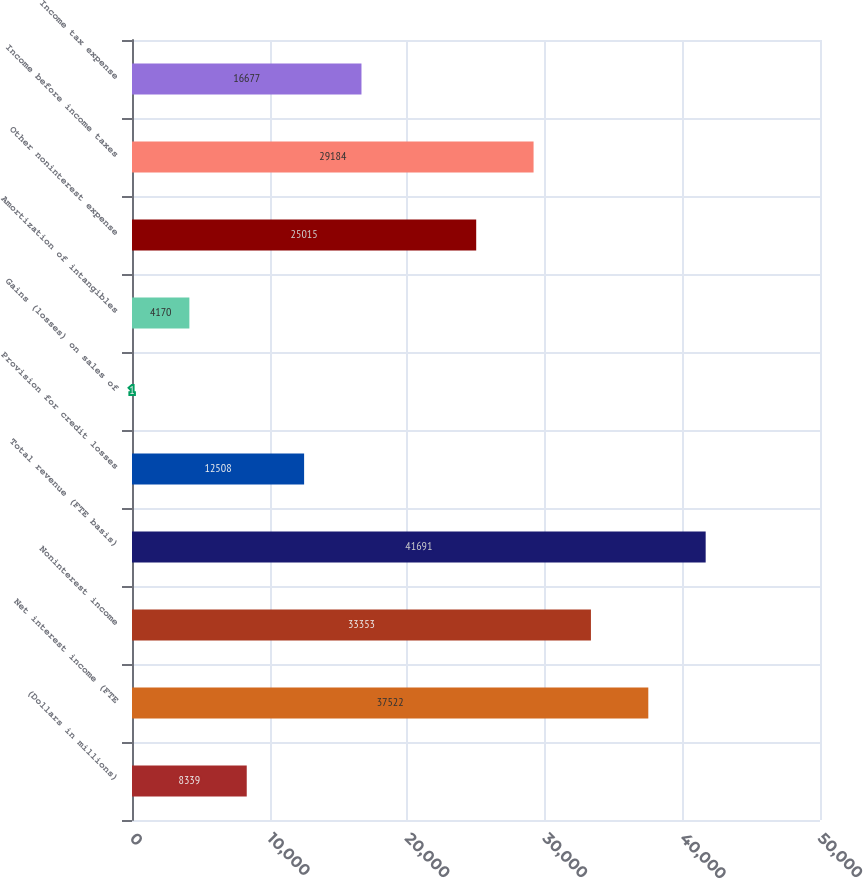Convert chart to OTSL. <chart><loc_0><loc_0><loc_500><loc_500><bar_chart><fcel>(Dollars in millions)<fcel>Net interest income (FTE<fcel>Noninterest income<fcel>Total revenue (FTE basis)<fcel>Provision for credit losses<fcel>Gains (losses) on sales of<fcel>Amortization of intangibles<fcel>Other noninterest expense<fcel>Income before income taxes<fcel>Income tax expense<nl><fcel>8339<fcel>37522<fcel>33353<fcel>41691<fcel>12508<fcel>1<fcel>4170<fcel>25015<fcel>29184<fcel>16677<nl></chart> 